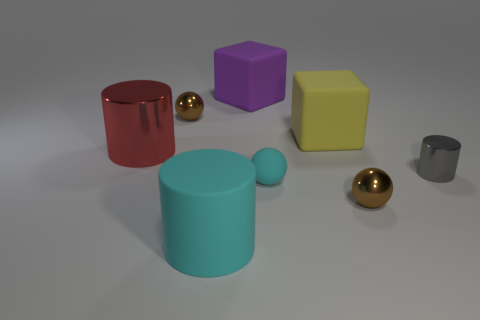There is a thing that is the same color as the rubber ball; what shape is it?
Offer a very short reply. Cylinder. What is the large block that is behind the yellow object made of?
Provide a short and direct response. Rubber. Is the number of gray shiny things in front of the yellow rubber cube less than the number of metal cylinders?
Provide a succinct answer. Yes. There is a brown thing in front of the rubber cube right of the large purple thing; what is its shape?
Your response must be concise. Sphere. What color is the large rubber cylinder?
Provide a succinct answer. Cyan. What number of other things are the same size as the rubber sphere?
Provide a short and direct response. 3. There is a object that is both behind the big yellow matte block and in front of the large purple block; what is its material?
Give a very brief answer. Metal. There is a metallic thing that is in front of the cyan sphere; is its size the same as the purple block?
Provide a short and direct response. No. Is the small rubber sphere the same color as the big matte cylinder?
Ensure brevity in your answer.  Yes. What number of big things are both behind the large cyan rubber thing and in front of the large purple matte cube?
Ensure brevity in your answer.  2. 